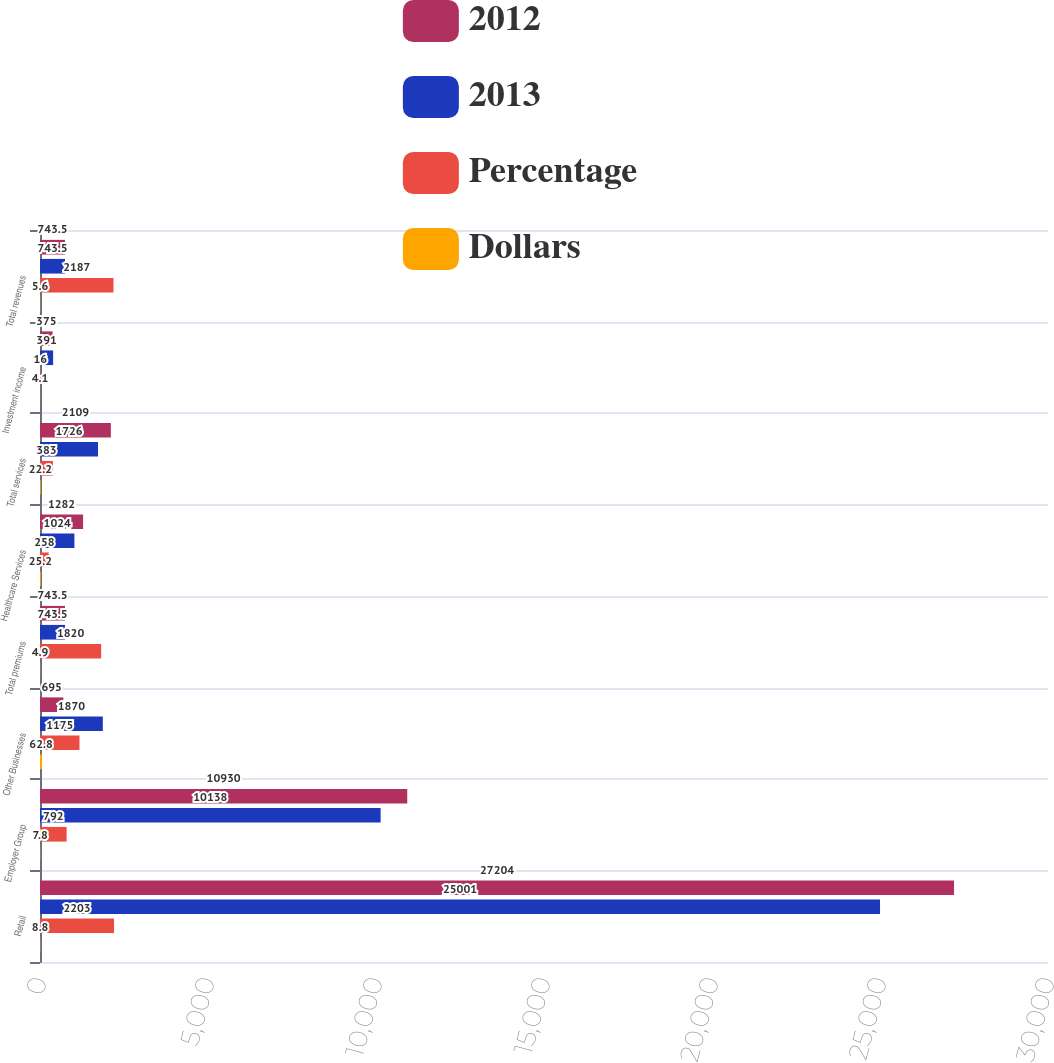Convert chart. <chart><loc_0><loc_0><loc_500><loc_500><stacked_bar_chart><ecel><fcel>Retail<fcel>Employer Group<fcel>Other Businesses<fcel>Total premiums<fcel>Healthcare Services<fcel>Total services<fcel>Investment income<fcel>Total revenues<nl><fcel>2012<fcel>27204<fcel>10930<fcel>695<fcel>743.5<fcel>1282<fcel>2109<fcel>375<fcel>743.5<nl><fcel>2013<fcel>25001<fcel>10138<fcel>1870<fcel>743.5<fcel>1024<fcel>1726<fcel>391<fcel>743.5<nl><fcel>Percentage<fcel>2203<fcel>792<fcel>1175<fcel>1820<fcel>258<fcel>383<fcel>16<fcel>2187<nl><fcel>Dollars<fcel>8.8<fcel>7.8<fcel>62.8<fcel>4.9<fcel>25.2<fcel>22.2<fcel>4.1<fcel>5.6<nl></chart> 